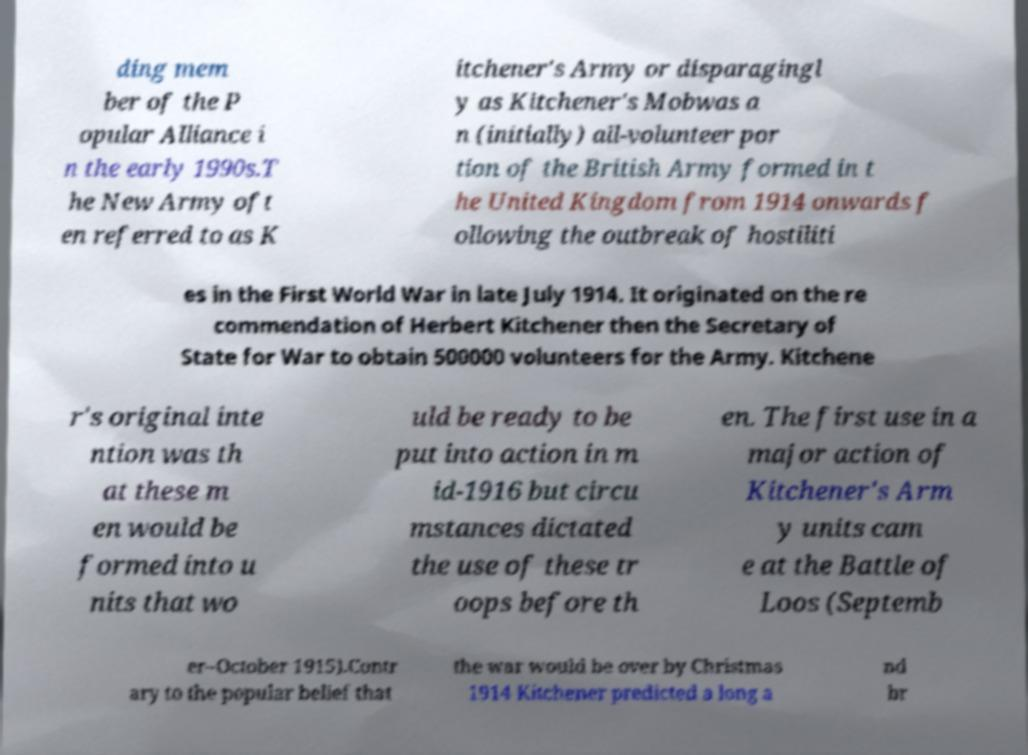Please read and relay the text visible in this image. What does it say? ding mem ber of the P opular Alliance i n the early 1990s.T he New Army oft en referred to as K itchener's Army or disparagingl y as Kitchener's Mobwas a n (initially) all-volunteer por tion of the British Army formed in t he United Kingdom from 1914 onwards f ollowing the outbreak of hostiliti es in the First World War in late July 1914. It originated on the re commendation of Herbert Kitchener then the Secretary of State for War to obtain 500000 volunteers for the Army. Kitchene r's original inte ntion was th at these m en would be formed into u nits that wo uld be ready to be put into action in m id-1916 but circu mstances dictated the use of these tr oops before th en. The first use in a major action of Kitchener's Arm y units cam e at the Battle of Loos (Septemb er–October 1915).Contr ary to the popular belief that the war would be over by Christmas 1914 Kitchener predicted a long a nd br 